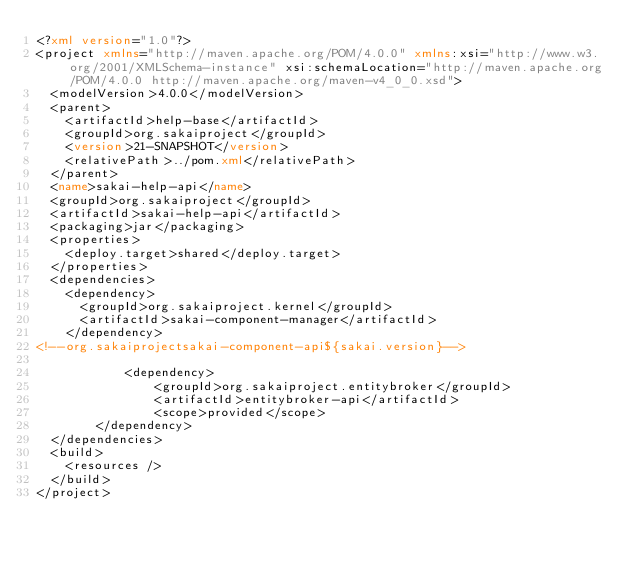Convert code to text. <code><loc_0><loc_0><loc_500><loc_500><_XML_><?xml version="1.0"?>
<project xmlns="http://maven.apache.org/POM/4.0.0" xmlns:xsi="http://www.w3.org/2001/XMLSchema-instance" xsi:schemaLocation="http://maven.apache.org/POM/4.0.0 http://maven.apache.org/maven-v4_0_0.xsd">
  <modelVersion>4.0.0</modelVersion>
  <parent>
    <artifactId>help-base</artifactId>
    <groupId>org.sakaiproject</groupId>
    <version>21-SNAPSHOT</version>
    <relativePath>../pom.xml</relativePath>
  </parent>
  <name>sakai-help-api</name>
  <groupId>org.sakaiproject</groupId>
  <artifactId>sakai-help-api</artifactId>
  <packaging>jar</packaging>
  <properties>
    <deploy.target>shared</deploy.target>
  </properties>
  <dependencies>
    <dependency>
      <groupId>org.sakaiproject.kernel</groupId>
      <artifactId>sakai-component-manager</artifactId>
    </dependency>
<!--org.sakaiprojectsakai-component-api${sakai.version}-->

            <dependency>
                <groupId>org.sakaiproject.entitybroker</groupId>
                <artifactId>entitybroker-api</artifactId>
                <scope>provided</scope>
        </dependency>
  </dependencies>
  <build>
    <resources />
  </build>
</project>
</code> 